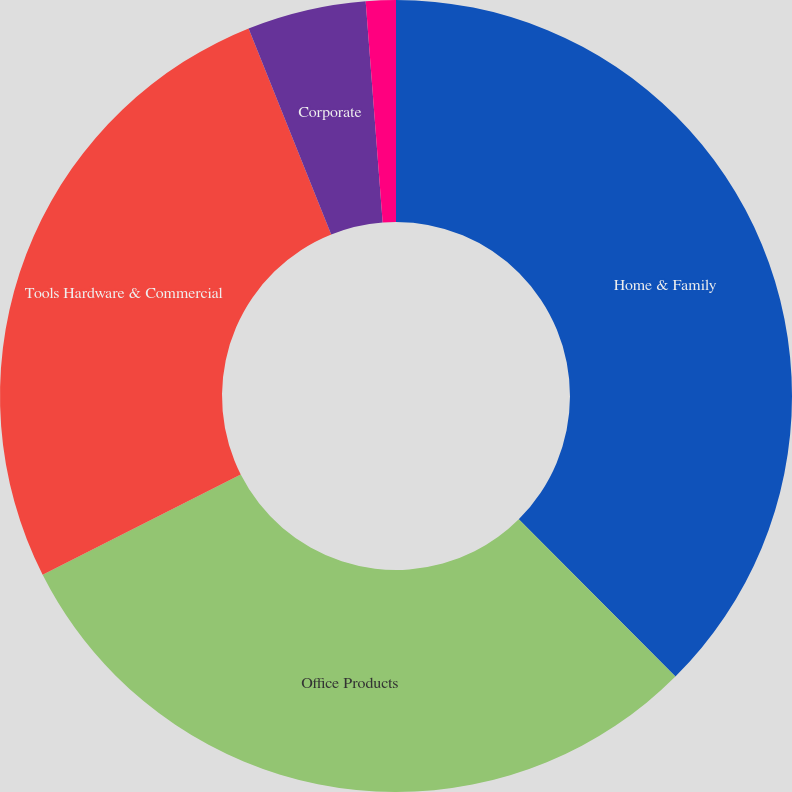<chart> <loc_0><loc_0><loc_500><loc_500><pie_chart><fcel>Home & Family<fcel>Office Products<fcel>Tools Hardware & Commercial<fcel>Corporate<fcel>Restructuring costs<nl><fcel>37.53%<fcel>30.01%<fcel>26.38%<fcel>4.85%<fcel>1.22%<nl></chart> 